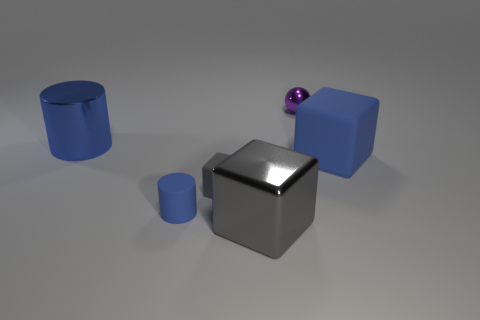Are there an equal number of small metallic objects in front of the small purple metallic thing and large blue objects that are in front of the matte cylinder?
Your response must be concise. Yes. There is a tiny rubber object to the right of the tiny blue rubber cylinder; what is its shape?
Your answer should be compact. Cube. There is a gray thing that is the same size as the sphere; what is its shape?
Provide a succinct answer. Cube. The cube that is in front of the gray thing behind the large cube on the left side of the large blue cube is what color?
Give a very brief answer. Gray. Do the tiny purple object and the blue shiny thing have the same shape?
Offer a terse response. No. Are there the same number of gray matte cubes that are behind the big cylinder and red cylinders?
Ensure brevity in your answer.  Yes. What number of other objects are there of the same material as the large blue cylinder?
Make the answer very short. 2. Is the size of the blue cylinder that is in front of the large rubber object the same as the gray cube that is in front of the blue rubber cylinder?
Provide a short and direct response. No. What number of things are either big blue things that are behind the big blue rubber cube or large blue objects that are left of the large gray object?
Offer a very short reply. 1. Is there any other thing that has the same shape as the purple thing?
Give a very brief answer. No. 